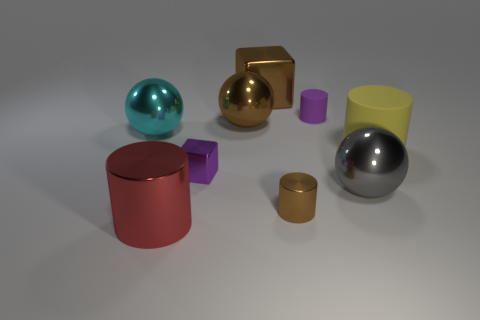What material is the tiny thing that is both right of the purple shiny block and behind the big gray metallic sphere?
Ensure brevity in your answer.  Rubber. There is a metallic cube that is the same color as the tiny rubber cylinder; what size is it?
Provide a succinct answer. Small. Is the shape of the small purple object that is right of the small purple metal block the same as the brown object in front of the gray object?
Your response must be concise. Yes. Are there any tiny cyan balls?
Keep it short and to the point. No. What is the color of the tiny rubber object that is the same shape as the big red metallic thing?
Your answer should be compact. Purple. There is a shiny cylinder that is the same size as the purple block; what is its color?
Make the answer very short. Brown. Is the material of the yellow object the same as the gray ball?
Give a very brief answer. No. What number of small rubber things are the same color as the big metallic block?
Make the answer very short. 0. Is the tiny cube the same color as the tiny rubber cylinder?
Your answer should be very brief. Yes. There is a large thing in front of the gray ball; what material is it?
Your answer should be compact. Metal. 